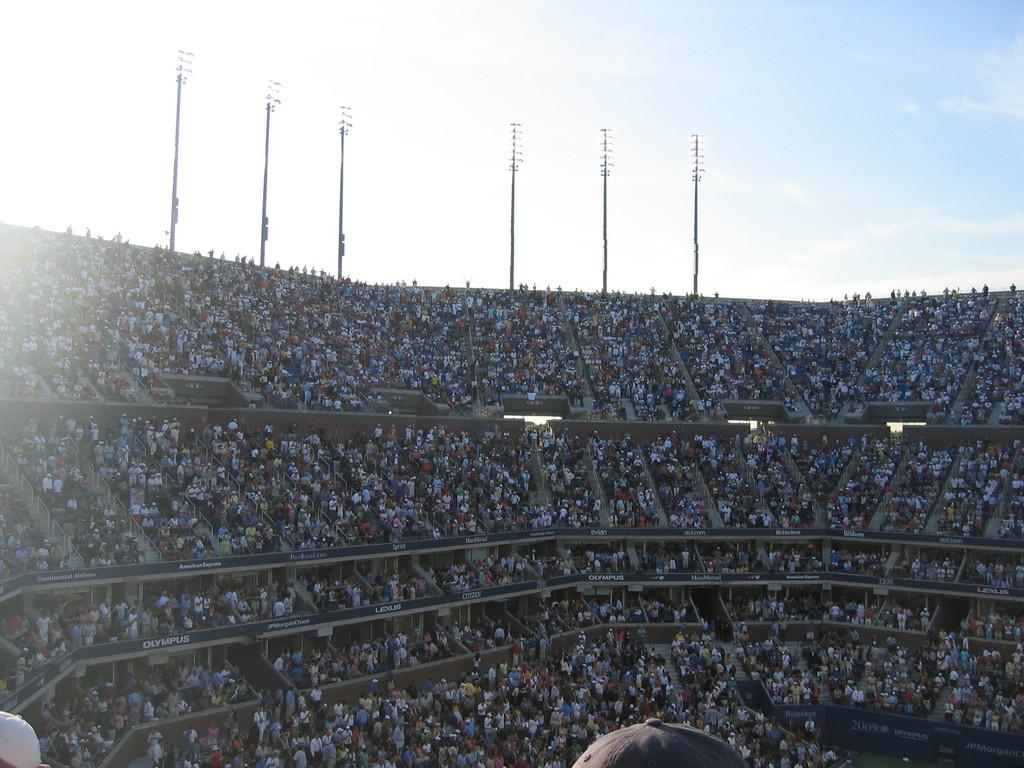What type of location is depicted in the image? The image shows a stadium view. Can you describe the people in the image? There are people in the image, but their specific actions or positions are not clear. What type of seating is available in the image? Chairs are visible in the image. How can people move between different levels in the image? Stairs are present in the image for people to move between levels. What is written on the board in the image? There is written text on a board in the image, but the content of the text is not clear. What structures are present to provide light in the image? Light poles are in the image to provide light. What is visible at the top of the image? The sky is visible at the top of the image. Can you tell me how many bears are visible in the image? There are no bears present in the image. What is the cause of the heat in the image? There is no indication of heat in the image, and the cause of any heat would not be visible in a still image. 